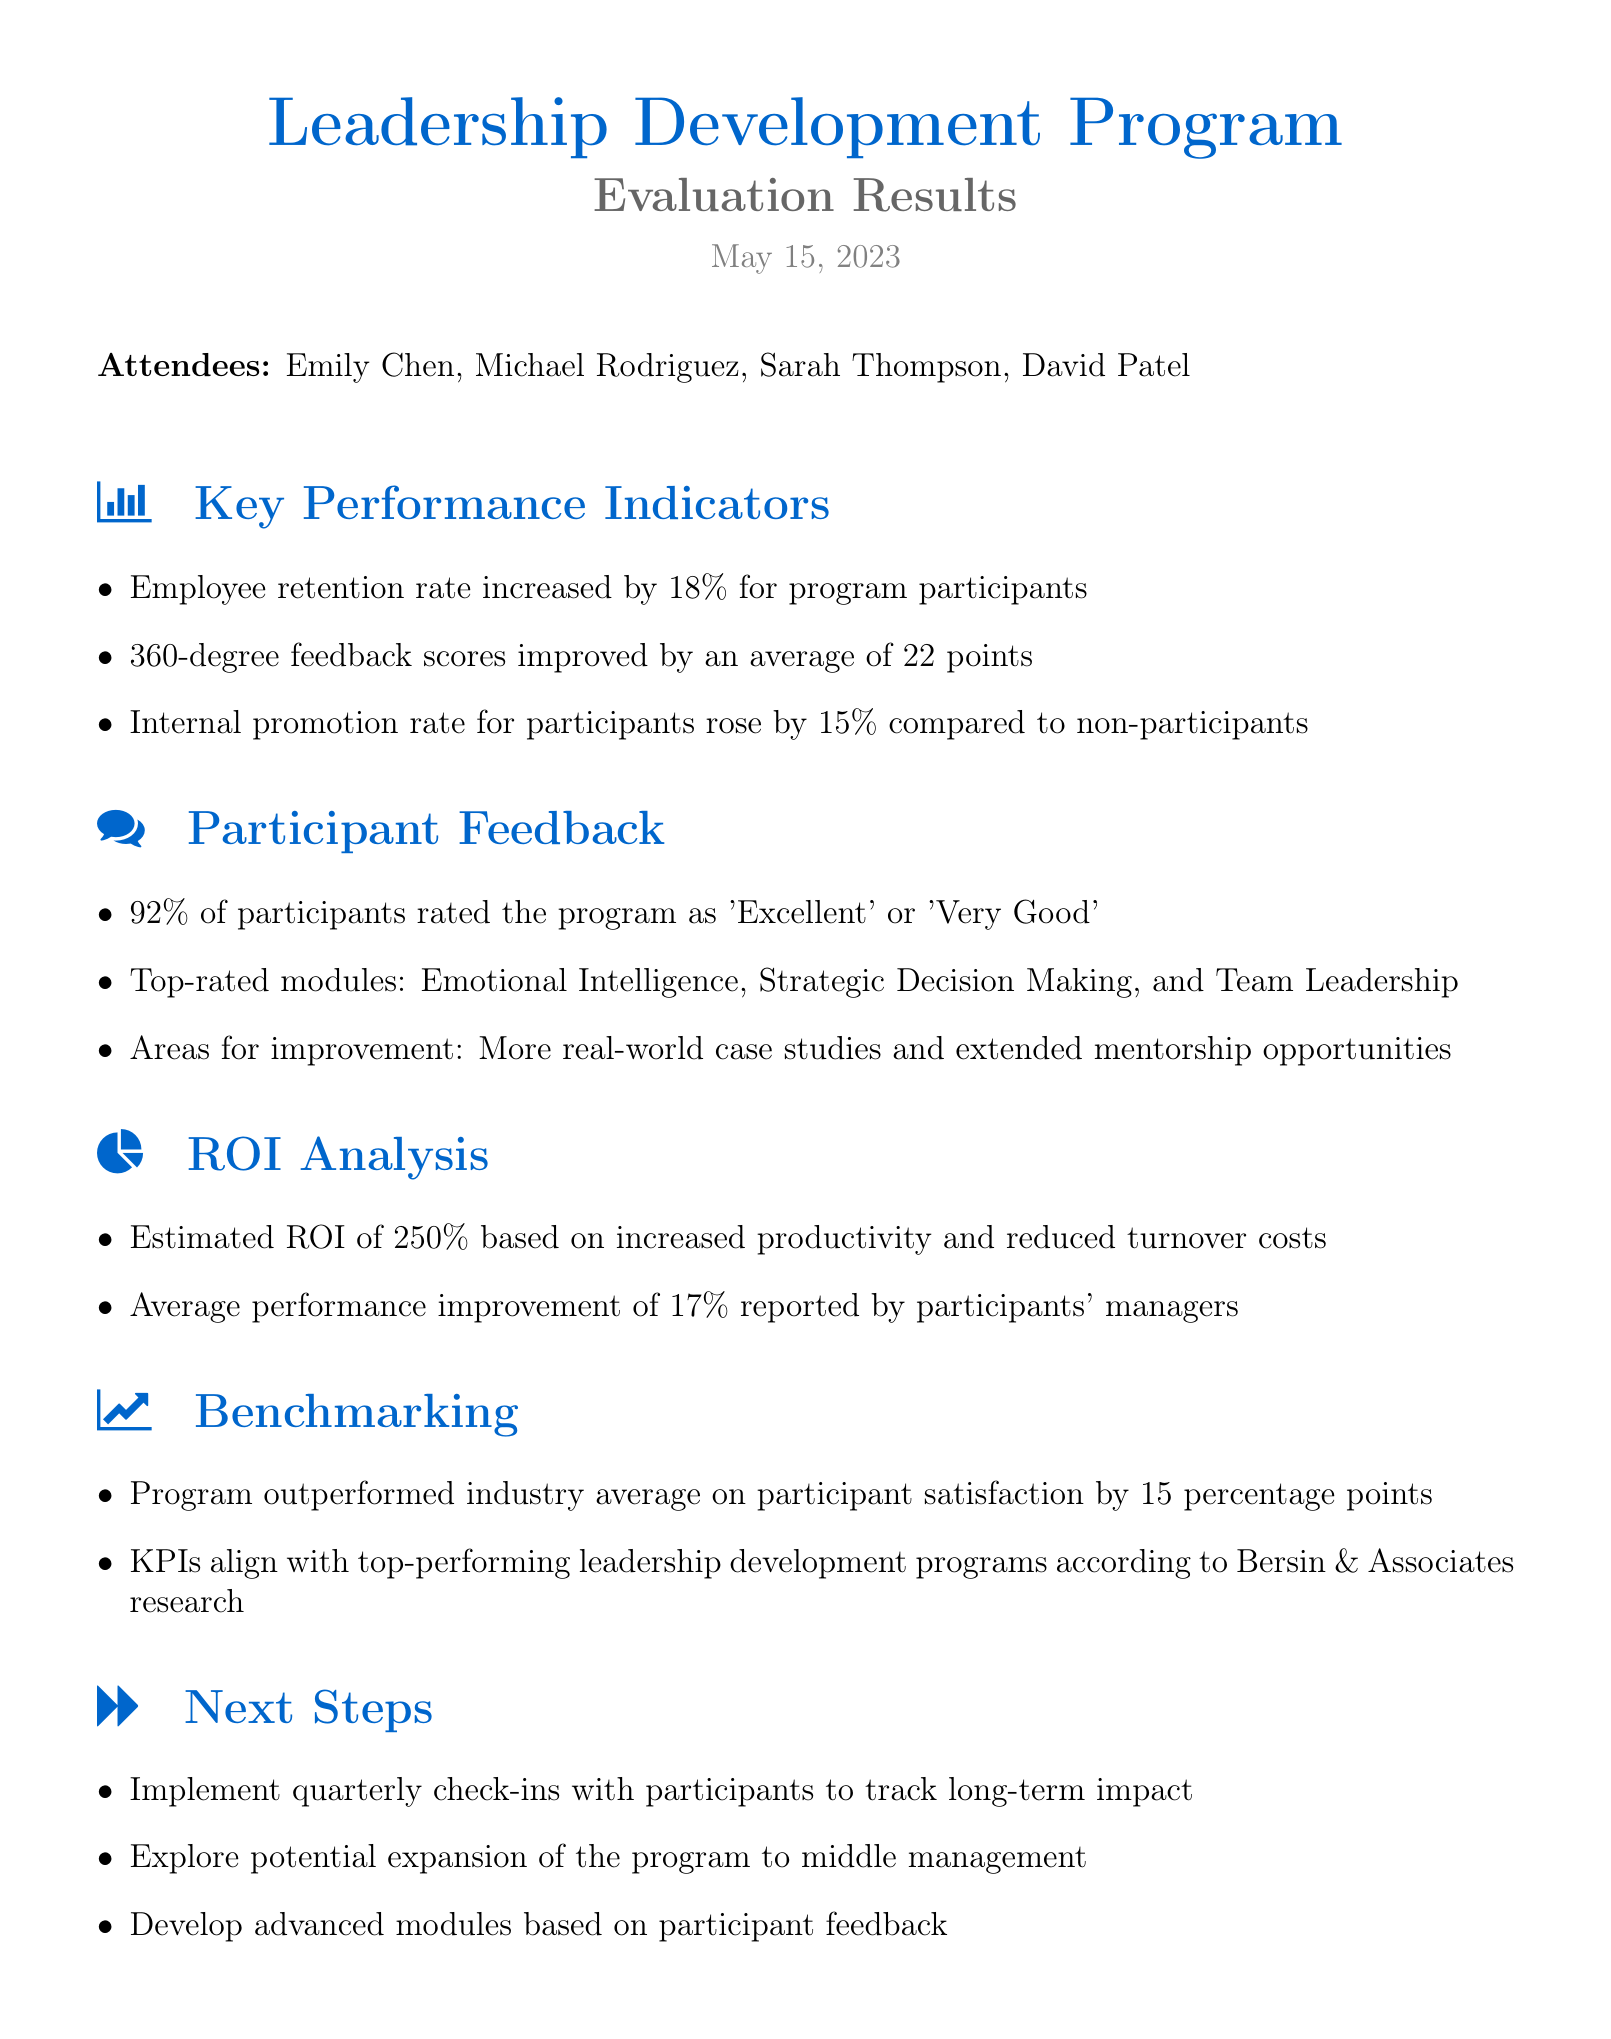What date was the meeting held? The date of the meeting is mentioned at the beginning of the document.
Answer: May 15, 2023 What percentage did the employee retention rate increase for program participants? The document states the specific percentage increase under Key Performance Indicators.
Answer: 18% What is the average improvement in 360-degree feedback scores? This figure is provided in the Key Performance Indicators section of the document.
Answer: 22 points What module was rated highest in the participant feedback? The document lists top-rated modules under the Participant Feedback section.
Answer: Emotional Intelligence What was the estimated ROI based on the program? This data is included in the ROI Analysis section of the document for financial evaluation.
Answer: 250% How much higher was participant satisfaction compared to the industry average? This information is included in the Benchmarking section regarding program effectiveness.
Answer: 15 percentage points What next step involves tracking long-term impact with participants? The Next Steps section outlines actions to be taken after the evaluation.
Answer: Implement quarterly check-ins Which executive attended the meeting? Attendees are listed at the beginning of the document, providing names and roles.
Answer: David Patel 